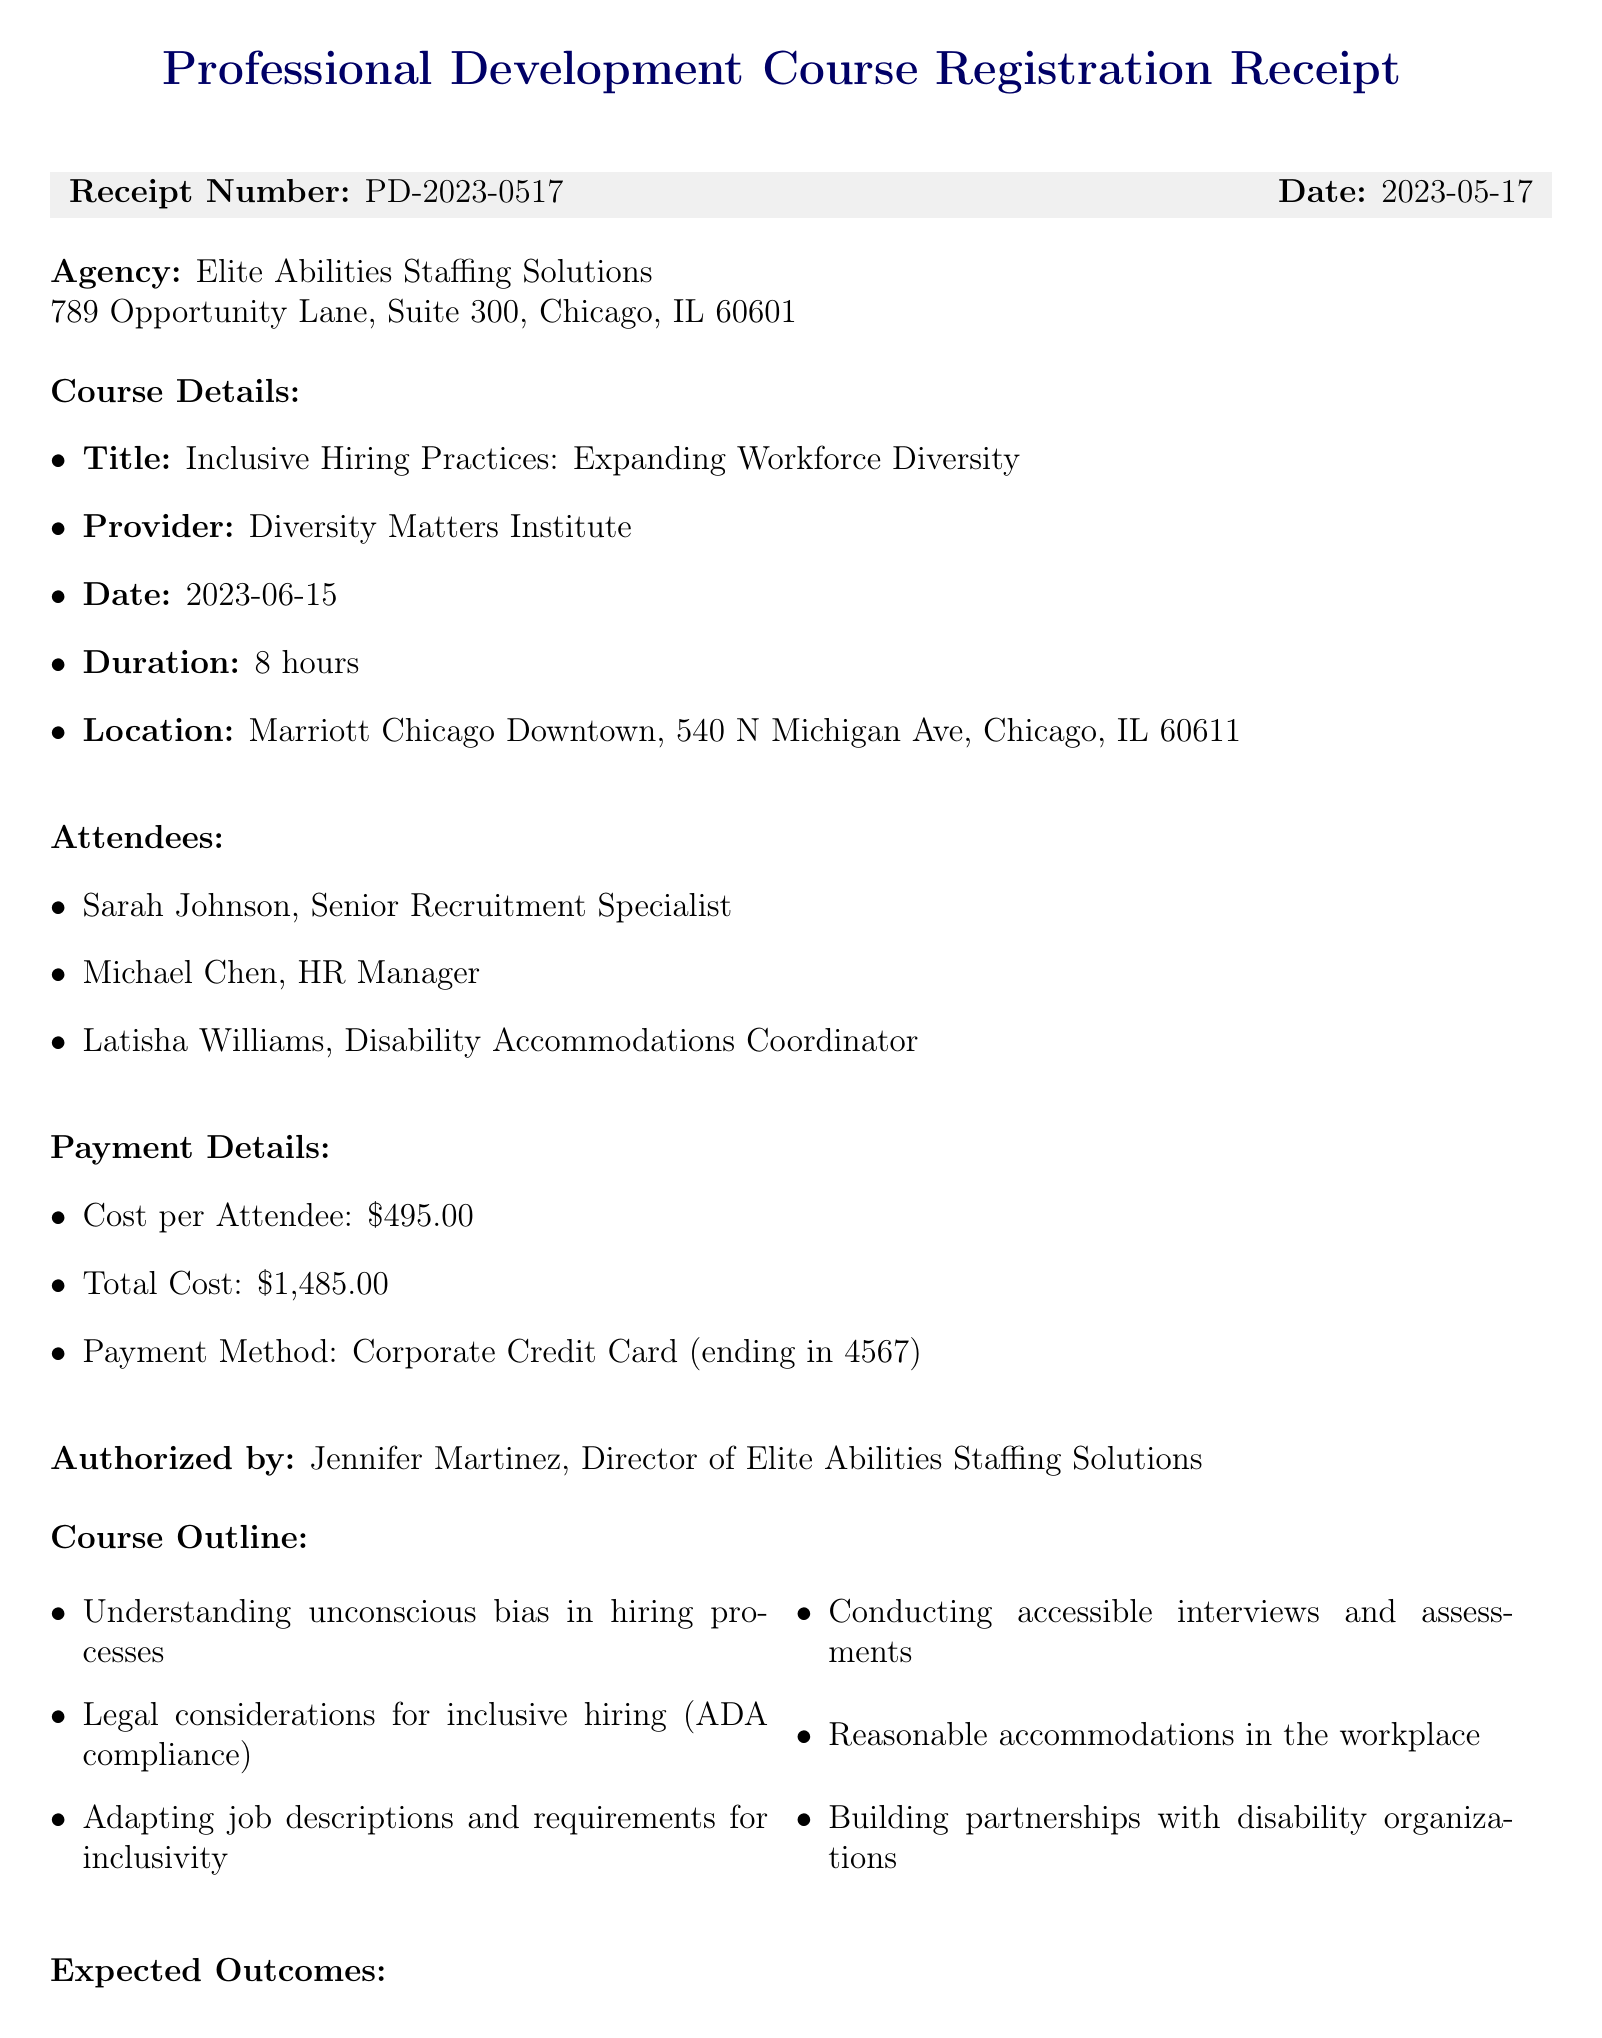What is the course title? The course title is specifically mentioned in the details section of the receipt as "Inclusive Hiring Practices: Expanding Workforce Diversity."
Answer: Inclusive Hiring Practices: Expanding Workforce Diversity Who authorized the payment? The authorized individual is identified in the document as the Director of the agency, which in this case is Jennifer Martinez.
Answer: Jennifer Martinez When is the course scheduled? The course date is explicitly provided in the receipt, indicating when the training will occur.
Answer: 2023-06-15 What is the total cost for the training? The total cost is calculated based on the number of attendees and cost per attendee which is stated in the payment details section of the document.
Answer: $1,485.00 How many hours does the course last? The course duration is specified in the document and gives the total time required for completion.
Answer: 8 hours What is one expected outcome of the course? The document lists several expected outcomes, and any of these can be an answer; one example is included in the outcomes section.
Answer: Enhanced ability to attract and retain diverse talent Where is the course being held? The course location is clearly mentioned in the details of the document, providing the physical address.
Answer: Marriott Chicago Downtown, 540 N Michigan Ave, Chicago, IL 60611 How many attendees are registered for the course? The document lists three individuals who will attend the course, which can be counted directly from the attendees section.
Answer: 3 What type of payment was used? The payment method is outlined in the payment details section of the receipt, indicating how the transaction was processed.
Answer: Corporate Credit Card (ending in 4567) 